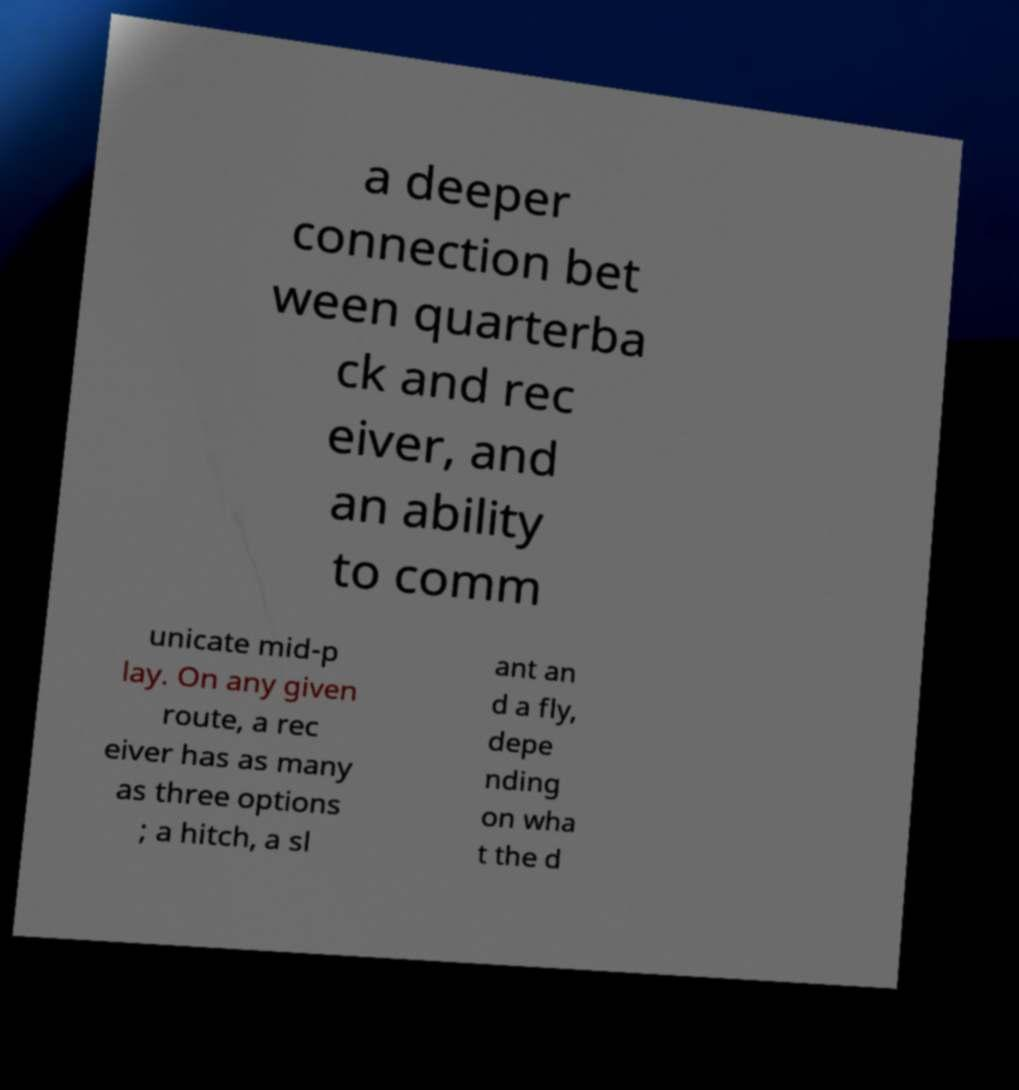Can you read and provide the text displayed in the image?This photo seems to have some interesting text. Can you extract and type it out for me? a deeper connection bet ween quarterba ck and rec eiver, and an ability to comm unicate mid-p lay. On any given route, a rec eiver has as many as three options ; a hitch, a sl ant an d a fly, depe nding on wha t the d 